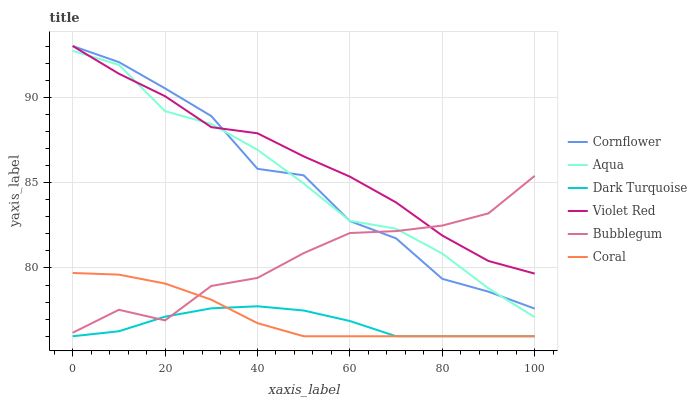Does Violet Red have the minimum area under the curve?
Answer yes or no. No. Does Dark Turquoise have the maximum area under the curve?
Answer yes or no. No. Is Violet Red the smoothest?
Answer yes or no. No. Is Violet Red the roughest?
Answer yes or no. No. Does Violet Red have the lowest value?
Answer yes or no. No. Does Dark Turquoise have the highest value?
Answer yes or no. No. Is Coral less than Violet Red?
Answer yes or no. Yes. Is Cornflower greater than Dark Turquoise?
Answer yes or no. Yes. Does Coral intersect Violet Red?
Answer yes or no. No. 